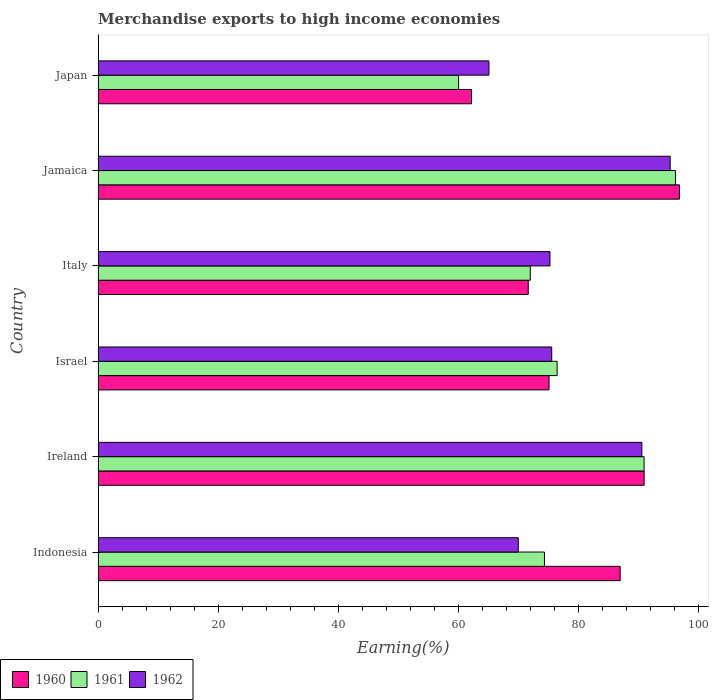How many groups of bars are there?
Give a very brief answer. 6. What is the percentage of amount earned from merchandise exports in 1961 in Ireland?
Make the answer very short. 90.9. Across all countries, what is the maximum percentage of amount earned from merchandise exports in 1961?
Make the answer very short. 96.13. Across all countries, what is the minimum percentage of amount earned from merchandise exports in 1960?
Keep it short and to the point. 62.16. In which country was the percentage of amount earned from merchandise exports in 1960 maximum?
Your answer should be very brief. Jamaica. What is the total percentage of amount earned from merchandise exports in 1962 in the graph?
Provide a succinct answer. 471.54. What is the difference between the percentage of amount earned from merchandise exports in 1961 in Italy and that in Jamaica?
Make the answer very short. -24.18. What is the difference between the percentage of amount earned from merchandise exports in 1962 in Ireland and the percentage of amount earned from merchandise exports in 1961 in Jamaica?
Your response must be concise. -5.61. What is the average percentage of amount earned from merchandise exports in 1961 per country?
Provide a succinct answer. 78.29. What is the difference between the percentage of amount earned from merchandise exports in 1961 and percentage of amount earned from merchandise exports in 1960 in Indonesia?
Offer a terse response. -12.6. In how many countries, is the percentage of amount earned from merchandise exports in 1961 greater than 92 %?
Make the answer very short. 1. What is the ratio of the percentage of amount earned from merchandise exports in 1962 in Jamaica to that in Japan?
Offer a very short reply. 1.46. What is the difference between the highest and the second highest percentage of amount earned from merchandise exports in 1962?
Ensure brevity in your answer.  4.71. What is the difference between the highest and the lowest percentage of amount earned from merchandise exports in 1962?
Keep it short and to the point. 30.17. Is the sum of the percentage of amount earned from merchandise exports in 1962 in Indonesia and Ireland greater than the maximum percentage of amount earned from merchandise exports in 1960 across all countries?
Your response must be concise. Yes. What does the 3rd bar from the bottom in Italy represents?
Make the answer very short. 1962. Is it the case that in every country, the sum of the percentage of amount earned from merchandise exports in 1961 and percentage of amount earned from merchandise exports in 1960 is greater than the percentage of amount earned from merchandise exports in 1962?
Offer a terse response. Yes. How many countries are there in the graph?
Your answer should be compact. 6. What is the difference between two consecutive major ticks on the X-axis?
Provide a short and direct response. 20. Does the graph contain grids?
Your answer should be compact. No. Where does the legend appear in the graph?
Provide a short and direct response. Bottom left. How are the legend labels stacked?
Provide a short and direct response. Horizontal. What is the title of the graph?
Ensure brevity in your answer.  Merchandise exports to high income economies. What is the label or title of the X-axis?
Offer a very short reply. Earning(%). What is the label or title of the Y-axis?
Make the answer very short. Country. What is the Earning(%) in 1960 in Indonesia?
Give a very brief answer. 86.92. What is the Earning(%) of 1961 in Indonesia?
Provide a succinct answer. 74.31. What is the Earning(%) in 1962 in Indonesia?
Your answer should be very brief. 69.95. What is the Earning(%) of 1960 in Ireland?
Keep it short and to the point. 90.9. What is the Earning(%) in 1961 in Ireland?
Keep it short and to the point. 90.9. What is the Earning(%) in 1962 in Ireland?
Ensure brevity in your answer.  90.53. What is the Earning(%) in 1960 in Israel?
Ensure brevity in your answer.  75.07. What is the Earning(%) of 1961 in Israel?
Your response must be concise. 76.42. What is the Earning(%) of 1962 in Israel?
Provide a short and direct response. 75.52. What is the Earning(%) in 1960 in Italy?
Make the answer very short. 71.61. What is the Earning(%) in 1961 in Italy?
Keep it short and to the point. 71.95. What is the Earning(%) in 1962 in Italy?
Your response must be concise. 75.23. What is the Earning(%) of 1960 in Jamaica?
Provide a short and direct response. 96.78. What is the Earning(%) in 1961 in Jamaica?
Your answer should be compact. 96.13. What is the Earning(%) in 1962 in Jamaica?
Give a very brief answer. 95.24. What is the Earning(%) of 1960 in Japan?
Ensure brevity in your answer.  62.16. What is the Earning(%) in 1961 in Japan?
Offer a terse response. 60.02. What is the Earning(%) in 1962 in Japan?
Offer a terse response. 65.07. Across all countries, what is the maximum Earning(%) in 1960?
Offer a very short reply. 96.78. Across all countries, what is the maximum Earning(%) of 1961?
Give a very brief answer. 96.13. Across all countries, what is the maximum Earning(%) of 1962?
Your response must be concise. 95.24. Across all countries, what is the minimum Earning(%) of 1960?
Provide a succinct answer. 62.16. Across all countries, what is the minimum Earning(%) in 1961?
Offer a terse response. 60.02. Across all countries, what is the minimum Earning(%) of 1962?
Your response must be concise. 65.07. What is the total Earning(%) in 1960 in the graph?
Your answer should be compact. 483.44. What is the total Earning(%) of 1961 in the graph?
Your response must be concise. 469.73. What is the total Earning(%) in 1962 in the graph?
Offer a very short reply. 471.54. What is the difference between the Earning(%) of 1960 in Indonesia and that in Ireland?
Give a very brief answer. -3.98. What is the difference between the Earning(%) of 1961 in Indonesia and that in Ireland?
Provide a succinct answer. -16.58. What is the difference between the Earning(%) of 1962 in Indonesia and that in Ireland?
Your answer should be compact. -20.57. What is the difference between the Earning(%) of 1960 in Indonesia and that in Israel?
Ensure brevity in your answer.  11.85. What is the difference between the Earning(%) of 1961 in Indonesia and that in Israel?
Give a very brief answer. -2.11. What is the difference between the Earning(%) in 1962 in Indonesia and that in Israel?
Your response must be concise. -5.57. What is the difference between the Earning(%) of 1960 in Indonesia and that in Italy?
Your answer should be compact. 15.31. What is the difference between the Earning(%) in 1961 in Indonesia and that in Italy?
Offer a very short reply. 2.36. What is the difference between the Earning(%) in 1962 in Indonesia and that in Italy?
Ensure brevity in your answer.  -5.28. What is the difference between the Earning(%) of 1960 in Indonesia and that in Jamaica?
Make the answer very short. -9.86. What is the difference between the Earning(%) in 1961 in Indonesia and that in Jamaica?
Your response must be concise. -21.82. What is the difference between the Earning(%) in 1962 in Indonesia and that in Jamaica?
Your response must be concise. -25.29. What is the difference between the Earning(%) of 1960 in Indonesia and that in Japan?
Provide a short and direct response. 24.75. What is the difference between the Earning(%) of 1961 in Indonesia and that in Japan?
Your response must be concise. 14.29. What is the difference between the Earning(%) of 1962 in Indonesia and that in Japan?
Provide a short and direct response. 4.88. What is the difference between the Earning(%) in 1960 in Ireland and that in Israel?
Your answer should be compact. 15.83. What is the difference between the Earning(%) in 1961 in Ireland and that in Israel?
Ensure brevity in your answer.  14.48. What is the difference between the Earning(%) in 1962 in Ireland and that in Israel?
Provide a succinct answer. 15. What is the difference between the Earning(%) of 1960 in Ireland and that in Italy?
Keep it short and to the point. 19.29. What is the difference between the Earning(%) in 1961 in Ireland and that in Italy?
Offer a very short reply. 18.94. What is the difference between the Earning(%) of 1962 in Ireland and that in Italy?
Offer a very short reply. 15.3. What is the difference between the Earning(%) in 1960 in Ireland and that in Jamaica?
Provide a succinct answer. -5.88. What is the difference between the Earning(%) in 1961 in Ireland and that in Jamaica?
Offer a terse response. -5.24. What is the difference between the Earning(%) of 1962 in Ireland and that in Jamaica?
Make the answer very short. -4.71. What is the difference between the Earning(%) of 1960 in Ireland and that in Japan?
Provide a succinct answer. 28.74. What is the difference between the Earning(%) in 1961 in Ireland and that in Japan?
Your answer should be compact. 30.88. What is the difference between the Earning(%) of 1962 in Ireland and that in Japan?
Make the answer very short. 25.46. What is the difference between the Earning(%) of 1960 in Israel and that in Italy?
Your answer should be compact. 3.46. What is the difference between the Earning(%) in 1961 in Israel and that in Italy?
Offer a terse response. 4.47. What is the difference between the Earning(%) in 1962 in Israel and that in Italy?
Make the answer very short. 0.29. What is the difference between the Earning(%) in 1960 in Israel and that in Jamaica?
Provide a succinct answer. -21.71. What is the difference between the Earning(%) in 1961 in Israel and that in Jamaica?
Provide a succinct answer. -19.71. What is the difference between the Earning(%) in 1962 in Israel and that in Jamaica?
Ensure brevity in your answer.  -19.72. What is the difference between the Earning(%) of 1960 in Israel and that in Japan?
Offer a very short reply. 12.91. What is the difference between the Earning(%) of 1961 in Israel and that in Japan?
Your response must be concise. 16.4. What is the difference between the Earning(%) of 1962 in Israel and that in Japan?
Offer a very short reply. 10.45. What is the difference between the Earning(%) in 1960 in Italy and that in Jamaica?
Your answer should be compact. -25.17. What is the difference between the Earning(%) in 1961 in Italy and that in Jamaica?
Your answer should be compact. -24.18. What is the difference between the Earning(%) in 1962 in Italy and that in Jamaica?
Offer a very short reply. -20.01. What is the difference between the Earning(%) in 1960 in Italy and that in Japan?
Provide a succinct answer. 9.45. What is the difference between the Earning(%) in 1961 in Italy and that in Japan?
Ensure brevity in your answer.  11.93. What is the difference between the Earning(%) in 1962 in Italy and that in Japan?
Offer a very short reply. 10.16. What is the difference between the Earning(%) in 1960 in Jamaica and that in Japan?
Offer a very short reply. 34.62. What is the difference between the Earning(%) of 1961 in Jamaica and that in Japan?
Make the answer very short. 36.12. What is the difference between the Earning(%) in 1962 in Jamaica and that in Japan?
Make the answer very short. 30.17. What is the difference between the Earning(%) in 1960 in Indonesia and the Earning(%) in 1961 in Ireland?
Your answer should be very brief. -3.98. What is the difference between the Earning(%) of 1960 in Indonesia and the Earning(%) of 1962 in Ireland?
Your answer should be compact. -3.61. What is the difference between the Earning(%) of 1961 in Indonesia and the Earning(%) of 1962 in Ireland?
Ensure brevity in your answer.  -16.21. What is the difference between the Earning(%) of 1960 in Indonesia and the Earning(%) of 1961 in Israel?
Your response must be concise. 10.5. What is the difference between the Earning(%) of 1960 in Indonesia and the Earning(%) of 1962 in Israel?
Make the answer very short. 11.39. What is the difference between the Earning(%) in 1961 in Indonesia and the Earning(%) in 1962 in Israel?
Provide a short and direct response. -1.21. What is the difference between the Earning(%) of 1960 in Indonesia and the Earning(%) of 1961 in Italy?
Give a very brief answer. 14.96. What is the difference between the Earning(%) in 1960 in Indonesia and the Earning(%) in 1962 in Italy?
Offer a terse response. 11.69. What is the difference between the Earning(%) of 1961 in Indonesia and the Earning(%) of 1962 in Italy?
Ensure brevity in your answer.  -0.92. What is the difference between the Earning(%) in 1960 in Indonesia and the Earning(%) in 1961 in Jamaica?
Keep it short and to the point. -9.22. What is the difference between the Earning(%) of 1960 in Indonesia and the Earning(%) of 1962 in Jamaica?
Provide a short and direct response. -8.32. What is the difference between the Earning(%) in 1961 in Indonesia and the Earning(%) in 1962 in Jamaica?
Offer a very short reply. -20.93. What is the difference between the Earning(%) in 1960 in Indonesia and the Earning(%) in 1961 in Japan?
Your answer should be compact. 26.9. What is the difference between the Earning(%) in 1960 in Indonesia and the Earning(%) in 1962 in Japan?
Provide a short and direct response. 21.85. What is the difference between the Earning(%) in 1961 in Indonesia and the Earning(%) in 1962 in Japan?
Offer a terse response. 9.24. What is the difference between the Earning(%) of 1960 in Ireland and the Earning(%) of 1961 in Israel?
Your answer should be compact. 14.48. What is the difference between the Earning(%) of 1960 in Ireland and the Earning(%) of 1962 in Israel?
Your answer should be very brief. 15.38. What is the difference between the Earning(%) in 1961 in Ireland and the Earning(%) in 1962 in Israel?
Provide a succinct answer. 15.37. What is the difference between the Earning(%) of 1960 in Ireland and the Earning(%) of 1961 in Italy?
Give a very brief answer. 18.95. What is the difference between the Earning(%) of 1960 in Ireland and the Earning(%) of 1962 in Italy?
Give a very brief answer. 15.67. What is the difference between the Earning(%) in 1961 in Ireland and the Earning(%) in 1962 in Italy?
Offer a terse response. 15.67. What is the difference between the Earning(%) in 1960 in Ireland and the Earning(%) in 1961 in Jamaica?
Your response must be concise. -5.23. What is the difference between the Earning(%) of 1960 in Ireland and the Earning(%) of 1962 in Jamaica?
Offer a very short reply. -4.34. What is the difference between the Earning(%) in 1961 in Ireland and the Earning(%) in 1962 in Jamaica?
Make the answer very short. -4.34. What is the difference between the Earning(%) of 1960 in Ireland and the Earning(%) of 1961 in Japan?
Your answer should be very brief. 30.88. What is the difference between the Earning(%) in 1960 in Ireland and the Earning(%) in 1962 in Japan?
Your answer should be very brief. 25.83. What is the difference between the Earning(%) of 1961 in Ireland and the Earning(%) of 1962 in Japan?
Ensure brevity in your answer.  25.83. What is the difference between the Earning(%) in 1960 in Israel and the Earning(%) in 1961 in Italy?
Ensure brevity in your answer.  3.12. What is the difference between the Earning(%) of 1960 in Israel and the Earning(%) of 1962 in Italy?
Give a very brief answer. -0.16. What is the difference between the Earning(%) of 1961 in Israel and the Earning(%) of 1962 in Italy?
Make the answer very short. 1.19. What is the difference between the Earning(%) of 1960 in Israel and the Earning(%) of 1961 in Jamaica?
Make the answer very short. -21.06. What is the difference between the Earning(%) of 1960 in Israel and the Earning(%) of 1962 in Jamaica?
Offer a terse response. -20.17. What is the difference between the Earning(%) of 1961 in Israel and the Earning(%) of 1962 in Jamaica?
Provide a succinct answer. -18.82. What is the difference between the Earning(%) in 1960 in Israel and the Earning(%) in 1961 in Japan?
Keep it short and to the point. 15.05. What is the difference between the Earning(%) in 1960 in Israel and the Earning(%) in 1962 in Japan?
Your answer should be very brief. 10. What is the difference between the Earning(%) of 1961 in Israel and the Earning(%) of 1962 in Japan?
Provide a succinct answer. 11.35. What is the difference between the Earning(%) in 1960 in Italy and the Earning(%) in 1961 in Jamaica?
Offer a very short reply. -24.52. What is the difference between the Earning(%) of 1960 in Italy and the Earning(%) of 1962 in Jamaica?
Offer a very short reply. -23.63. What is the difference between the Earning(%) in 1961 in Italy and the Earning(%) in 1962 in Jamaica?
Your answer should be very brief. -23.29. What is the difference between the Earning(%) of 1960 in Italy and the Earning(%) of 1961 in Japan?
Provide a short and direct response. 11.59. What is the difference between the Earning(%) in 1960 in Italy and the Earning(%) in 1962 in Japan?
Your response must be concise. 6.54. What is the difference between the Earning(%) in 1961 in Italy and the Earning(%) in 1962 in Japan?
Make the answer very short. 6.88. What is the difference between the Earning(%) in 1960 in Jamaica and the Earning(%) in 1961 in Japan?
Your answer should be compact. 36.76. What is the difference between the Earning(%) of 1960 in Jamaica and the Earning(%) of 1962 in Japan?
Make the answer very short. 31.71. What is the difference between the Earning(%) in 1961 in Jamaica and the Earning(%) in 1962 in Japan?
Give a very brief answer. 31.06. What is the average Earning(%) of 1960 per country?
Your answer should be compact. 80.57. What is the average Earning(%) in 1961 per country?
Your answer should be compact. 78.29. What is the average Earning(%) of 1962 per country?
Ensure brevity in your answer.  78.59. What is the difference between the Earning(%) in 1960 and Earning(%) in 1961 in Indonesia?
Give a very brief answer. 12.6. What is the difference between the Earning(%) in 1960 and Earning(%) in 1962 in Indonesia?
Offer a very short reply. 16.96. What is the difference between the Earning(%) of 1961 and Earning(%) of 1962 in Indonesia?
Ensure brevity in your answer.  4.36. What is the difference between the Earning(%) of 1960 and Earning(%) of 1961 in Ireland?
Offer a very short reply. 0. What is the difference between the Earning(%) of 1960 and Earning(%) of 1962 in Ireland?
Your response must be concise. 0.37. What is the difference between the Earning(%) of 1961 and Earning(%) of 1962 in Ireland?
Offer a very short reply. 0.37. What is the difference between the Earning(%) of 1960 and Earning(%) of 1961 in Israel?
Your response must be concise. -1.35. What is the difference between the Earning(%) of 1960 and Earning(%) of 1962 in Israel?
Make the answer very short. -0.45. What is the difference between the Earning(%) in 1961 and Earning(%) in 1962 in Israel?
Ensure brevity in your answer.  0.9. What is the difference between the Earning(%) in 1960 and Earning(%) in 1961 in Italy?
Offer a very short reply. -0.34. What is the difference between the Earning(%) in 1960 and Earning(%) in 1962 in Italy?
Your answer should be very brief. -3.62. What is the difference between the Earning(%) of 1961 and Earning(%) of 1962 in Italy?
Your response must be concise. -3.28. What is the difference between the Earning(%) in 1960 and Earning(%) in 1961 in Jamaica?
Offer a terse response. 0.65. What is the difference between the Earning(%) in 1960 and Earning(%) in 1962 in Jamaica?
Offer a very short reply. 1.54. What is the difference between the Earning(%) of 1961 and Earning(%) of 1962 in Jamaica?
Give a very brief answer. 0.89. What is the difference between the Earning(%) of 1960 and Earning(%) of 1961 in Japan?
Provide a succinct answer. 2.15. What is the difference between the Earning(%) of 1960 and Earning(%) of 1962 in Japan?
Make the answer very short. -2.91. What is the difference between the Earning(%) of 1961 and Earning(%) of 1962 in Japan?
Ensure brevity in your answer.  -5.05. What is the ratio of the Earning(%) in 1960 in Indonesia to that in Ireland?
Your answer should be compact. 0.96. What is the ratio of the Earning(%) of 1961 in Indonesia to that in Ireland?
Your answer should be very brief. 0.82. What is the ratio of the Earning(%) of 1962 in Indonesia to that in Ireland?
Give a very brief answer. 0.77. What is the ratio of the Earning(%) in 1960 in Indonesia to that in Israel?
Make the answer very short. 1.16. What is the ratio of the Earning(%) in 1961 in Indonesia to that in Israel?
Give a very brief answer. 0.97. What is the ratio of the Earning(%) of 1962 in Indonesia to that in Israel?
Give a very brief answer. 0.93. What is the ratio of the Earning(%) in 1960 in Indonesia to that in Italy?
Offer a terse response. 1.21. What is the ratio of the Earning(%) of 1961 in Indonesia to that in Italy?
Offer a very short reply. 1.03. What is the ratio of the Earning(%) of 1962 in Indonesia to that in Italy?
Provide a short and direct response. 0.93. What is the ratio of the Earning(%) of 1960 in Indonesia to that in Jamaica?
Give a very brief answer. 0.9. What is the ratio of the Earning(%) of 1961 in Indonesia to that in Jamaica?
Your answer should be very brief. 0.77. What is the ratio of the Earning(%) of 1962 in Indonesia to that in Jamaica?
Offer a terse response. 0.73. What is the ratio of the Earning(%) of 1960 in Indonesia to that in Japan?
Ensure brevity in your answer.  1.4. What is the ratio of the Earning(%) in 1961 in Indonesia to that in Japan?
Give a very brief answer. 1.24. What is the ratio of the Earning(%) in 1962 in Indonesia to that in Japan?
Ensure brevity in your answer.  1.07. What is the ratio of the Earning(%) in 1960 in Ireland to that in Israel?
Offer a very short reply. 1.21. What is the ratio of the Earning(%) in 1961 in Ireland to that in Israel?
Your answer should be very brief. 1.19. What is the ratio of the Earning(%) of 1962 in Ireland to that in Israel?
Provide a succinct answer. 1.2. What is the ratio of the Earning(%) of 1960 in Ireland to that in Italy?
Keep it short and to the point. 1.27. What is the ratio of the Earning(%) of 1961 in Ireland to that in Italy?
Provide a succinct answer. 1.26. What is the ratio of the Earning(%) of 1962 in Ireland to that in Italy?
Offer a very short reply. 1.2. What is the ratio of the Earning(%) of 1960 in Ireland to that in Jamaica?
Your answer should be compact. 0.94. What is the ratio of the Earning(%) in 1961 in Ireland to that in Jamaica?
Make the answer very short. 0.95. What is the ratio of the Earning(%) of 1962 in Ireland to that in Jamaica?
Make the answer very short. 0.95. What is the ratio of the Earning(%) of 1960 in Ireland to that in Japan?
Provide a short and direct response. 1.46. What is the ratio of the Earning(%) in 1961 in Ireland to that in Japan?
Offer a very short reply. 1.51. What is the ratio of the Earning(%) of 1962 in Ireland to that in Japan?
Offer a terse response. 1.39. What is the ratio of the Earning(%) in 1960 in Israel to that in Italy?
Provide a short and direct response. 1.05. What is the ratio of the Earning(%) of 1961 in Israel to that in Italy?
Offer a terse response. 1.06. What is the ratio of the Earning(%) of 1962 in Israel to that in Italy?
Offer a terse response. 1. What is the ratio of the Earning(%) of 1960 in Israel to that in Jamaica?
Your response must be concise. 0.78. What is the ratio of the Earning(%) in 1961 in Israel to that in Jamaica?
Your response must be concise. 0.79. What is the ratio of the Earning(%) of 1962 in Israel to that in Jamaica?
Your answer should be compact. 0.79. What is the ratio of the Earning(%) of 1960 in Israel to that in Japan?
Offer a very short reply. 1.21. What is the ratio of the Earning(%) in 1961 in Israel to that in Japan?
Give a very brief answer. 1.27. What is the ratio of the Earning(%) of 1962 in Israel to that in Japan?
Provide a short and direct response. 1.16. What is the ratio of the Earning(%) in 1960 in Italy to that in Jamaica?
Ensure brevity in your answer.  0.74. What is the ratio of the Earning(%) in 1961 in Italy to that in Jamaica?
Keep it short and to the point. 0.75. What is the ratio of the Earning(%) of 1962 in Italy to that in Jamaica?
Make the answer very short. 0.79. What is the ratio of the Earning(%) in 1960 in Italy to that in Japan?
Offer a terse response. 1.15. What is the ratio of the Earning(%) of 1961 in Italy to that in Japan?
Make the answer very short. 1.2. What is the ratio of the Earning(%) of 1962 in Italy to that in Japan?
Your response must be concise. 1.16. What is the ratio of the Earning(%) in 1960 in Jamaica to that in Japan?
Give a very brief answer. 1.56. What is the ratio of the Earning(%) of 1961 in Jamaica to that in Japan?
Provide a short and direct response. 1.6. What is the ratio of the Earning(%) in 1962 in Jamaica to that in Japan?
Make the answer very short. 1.46. What is the difference between the highest and the second highest Earning(%) in 1960?
Provide a succinct answer. 5.88. What is the difference between the highest and the second highest Earning(%) of 1961?
Your answer should be compact. 5.24. What is the difference between the highest and the second highest Earning(%) of 1962?
Ensure brevity in your answer.  4.71. What is the difference between the highest and the lowest Earning(%) of 1960?
Offer a terse response. 34.62. What is the difference between the highest and the lowest Earning(%) of 1961?
Make the answer very short. 36.12. What is the difference between the highest and the lowest Earning(%) of 1962?
Offer a terse response. 30.17. 